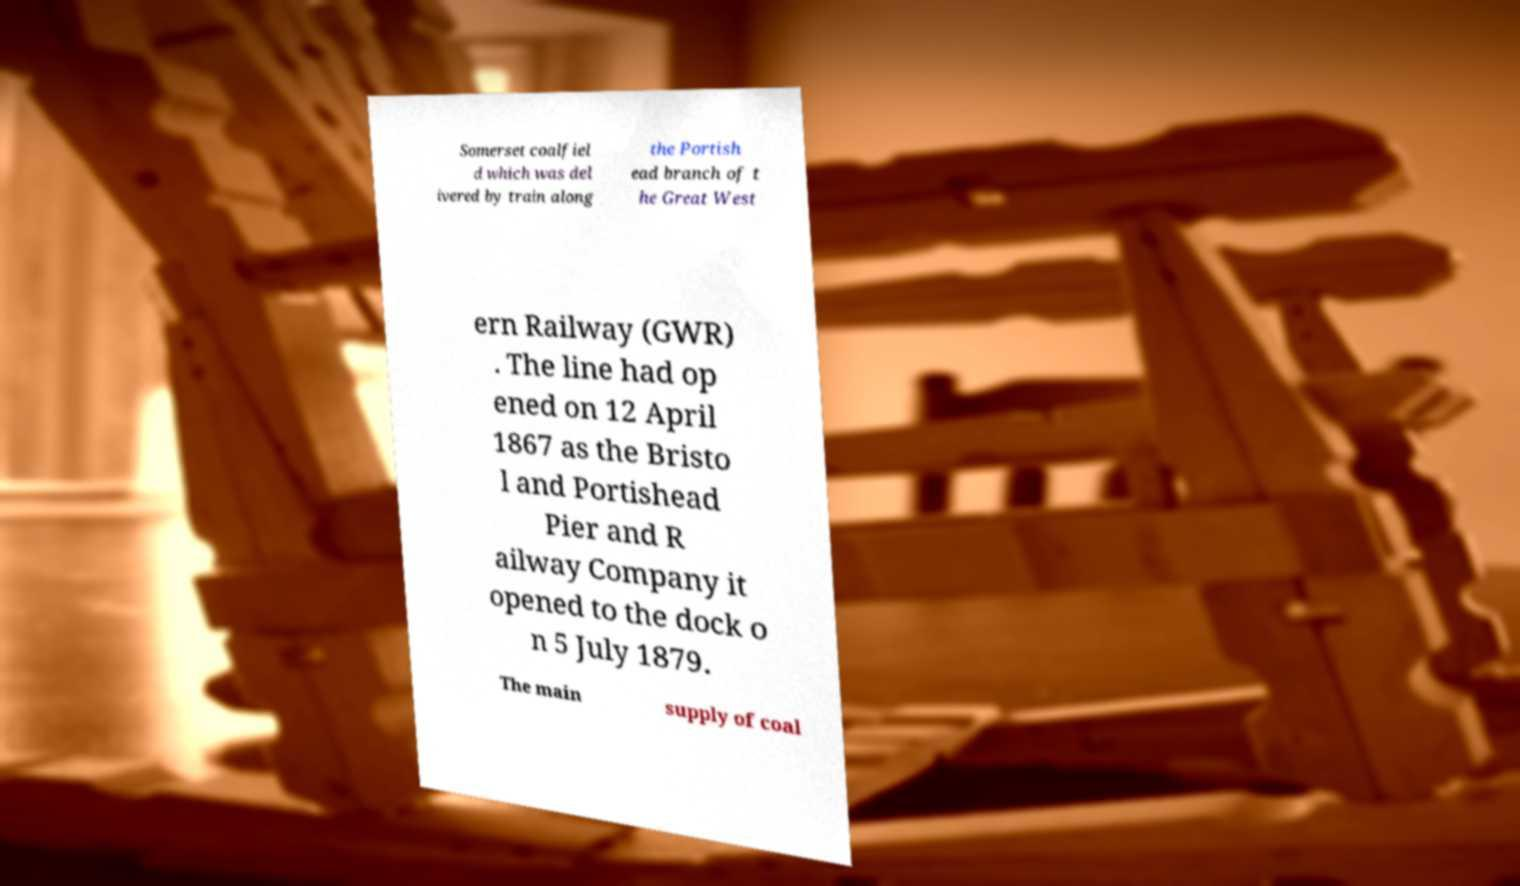Please read and relay the text visible in this image. What does it say? Somerset coalfiel d which was del ivered by train along the Portish ead branch of t he Great West ern Railway (GWR) . The line had op ened on 12 April 1867 as the Bristo l and Portishead Pier and R ailway Company it opened to the dock o n 5 July 1879. The main supply of coal 